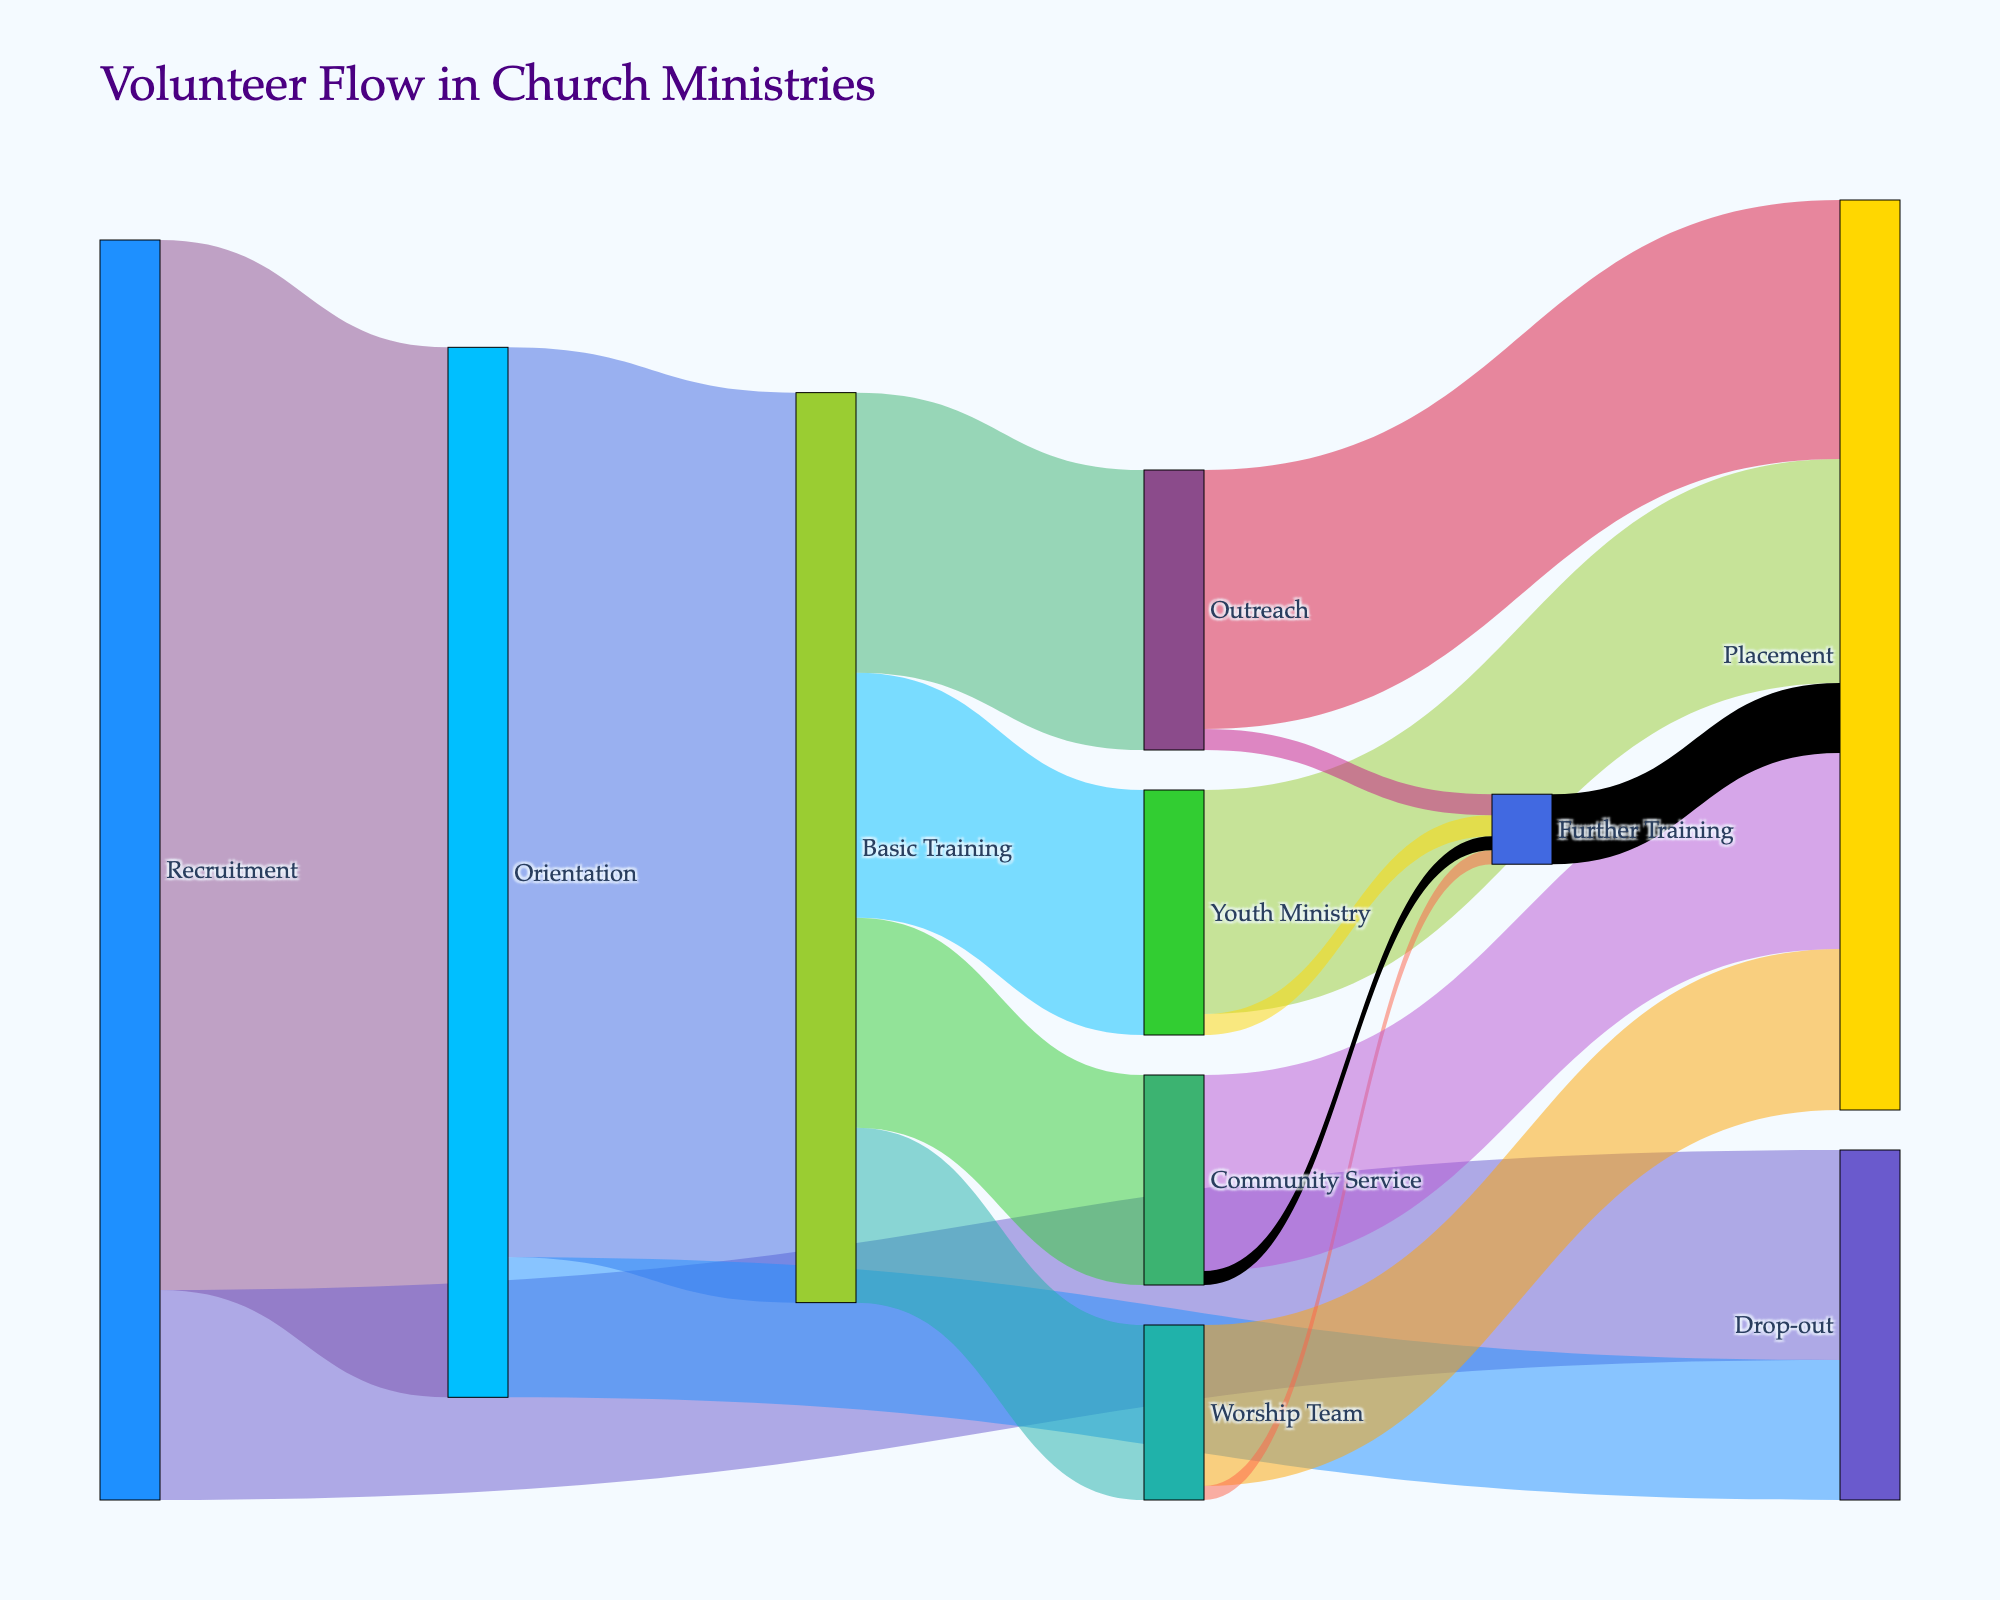What's the title of the figure? The title is typically located at the top of the diagram. It gives a brief overview of what the figure is about.
Answer: Volunteer Flow in Church Ministries How many volunteers completed Orientation and started Basic Training? Look at the flow from Orientation to Basic Training. The figure shows this flow with a specific value.
Answer: 130 Which stage has the highest number of volunteers dropping out? Compare the value of drop-outs from Recruitment and Orientation. Recruitment has a drop-out value of 30, while Orientation has 20.
Answer: Recruitment How many volunteers are placed in Youth Ministry through Basic Training? Locate the flow from Basic Training to Youth Ministry. The value of this flow is indicated in the figure.
Answer: 35 How many volunteers went through Further Training before Placement? To answer this, observe the flows going into and from Further Training. The total number flowing from Further Training to Placement is the desired value.
Answer: 10 How many more volunteers finished Placement through Outreach compared to Worship Team? Identify the values for the placements from Outreach and Worship Team. Outreach placement is 37, and Worship Team is 23. Calculate the difference: 37 - 23.
Answer: 14 What is the total number of volunteers that completed any kind of Training after Orientation? Consider the flows from Orientation to Basic Training (130). From Basic Training, look at all the paths to various ministries and Community Service (35 + 25 + 40 + 30) and Further Training (3 + 2 + 3 + 2). Sum up these values: 130 (orientated to trained).
Answer: 130 Which ministry received the least number of volunteers from Basic Training? Compare the values of volunteers going to different ministries: Youth Ministry (35), Worship Team (25), Outreach (40), Community Service (30). Worship Team has the least.
Answer: Worship Team How many volunteers are placed in any ministry or project after completing Further Training? Observe the further training outgoing flow to Placement (10). This is the total number of volunteers placed after Further Training.
Answer: 10 What is the total number of volunteers that reached Placement across all stages? Add up all the flows that terminate in Placement: Youth Ministry (32), Worship Team (23), Outreach (37), Community Service (28), Further Training (10). Total is 32 + 23 + 37 + 28 + 10.
Answer: 130 